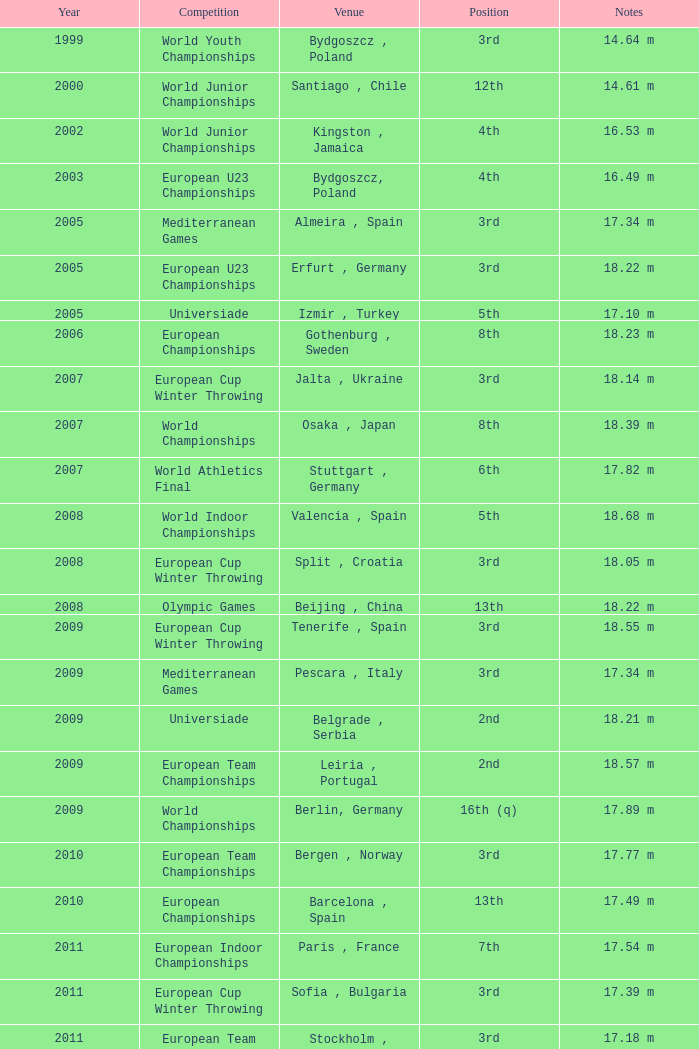What is the placement of 1999? 3rd. 